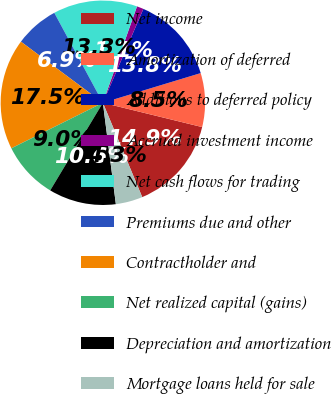Convert chart. <chart><loc_0><loc_0><loc_500><loc_500><pie_chart><fcel>Net income<fcel>Amortization of deferred<fcel>Additions to deferred policy<fcel>Accrued investment income<fcel>Net cash flows for trading<fcel>Premiums due and other<fcel>Contractholder and<fcel>Net realized capital (gains)<fcel>Depreciation and amortization<fcel>Mortgage loans held for sale<nl><fcel>14.89%<fcel>8.51%<fcel>13.83%<fcel>1.07%<fcel>13.3%<fcel>6.92%<fcel>17.55%<fcel>9.04%<fcel>10.64%<fcel>4.26%<nl></chart> 